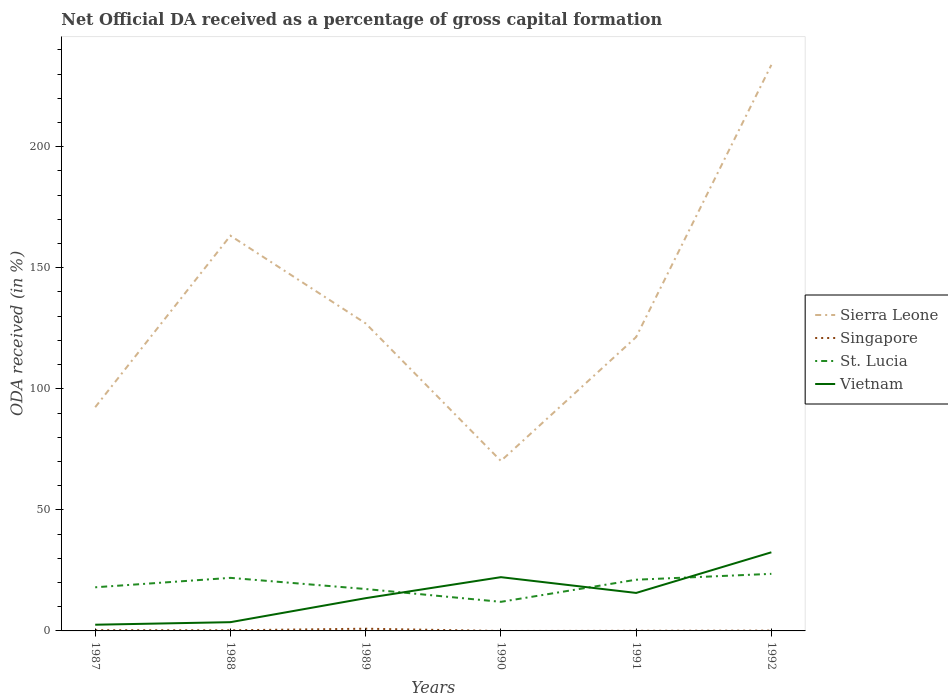Is the number of lines equal to the number of legend labels?
Your answer should be very brief. No. Across all years, what is the maximum net ODA received in Sierra Leone?
Provide a succinct answer. 70.21. What is the total net ODA received in Vietnam in the graph?
Your answer should be compact. -2.16. What is the difference between the highest and the second highest net ODA received in Sierra Leone?
Give a very brief answer. 163.58. How many years are there in the graph?
Offer a terse response. 6. Are the values on the major ticks of Y-axis written in scientific E-notation?
Give a very brief answer. No. Where does the legend appear in the graph?
Your answer should be compact. Center right. How are the legend labels stacked?
Provide a short and direct response. Vertical. What is the title of the graph?
Provide a short and direct response. Net Official DA received as a percentage of gross capital formation. Does "Faeroe Islands" appear as one of the legend labels in the graph?
Keep it short and to the point. No. What is the label or title of the Y-axis?
Provide a short and direct response. ODA received (in %). What is the ODA received (in %) of Sierra Leone in 1987?
Your answer should be very brief. 92.41. What is the ODA received (in %) in Singapore in 1987?
Offer a very short reply. 0.3. What is the ODA received (in %) of St. Lucia in 1987?
Provide a succinct answer. 18.02. What is the ODA received (in %) of Vietnam in 1987?
Make the answer very short. 2.56. What is the ODA received (in %) of Sierra Leone in 1988?
Your answer should be compact. 163.25. What is the ODA received (in %) in Singapore in 1988?
Provide a succinct answer. 0.26. What is the ODA received (in %) in St. Lucia in 1988?
Your response must be concise. 21.92. What is the ODA received (in %) of Vietnam in 1988?
Ensure brevity in your answer.  3.61. What is the ODA received (in %) in Sierra Leone in 1989?
Provide a succinct answer. 127.02. What is the ODA received (in %) in Singapore in 1989?
Make the answer very short. 0.91. What is the ODA received (in %) in St. Lucia in 1989?
Ensure brevity in your answer.  17.31. What is the ODA received (in %) in Vietnam in 1989?
Offer a terse response. 13.53. What is the ODA received (in %) of Sierra Leone in 1990?
Offer a terse response. 70.21. What is the ODA received (in %) in St. Lucia in 1990?
Your answer should be very brief. 12.02. What is the ODA received (in %) of Vietnam in 1990?
Offer a very short reply. 22.2. What is the ODA received (in %) in Sierra Leone in 1991?
Offer a very short reply. 121.37. What is the ODA received (in %) of Singapore in 1991?
Your answer should be very brief. 0.05. What is the ODA received (in %) of St. Lucia in 1991?
Make the answer very short. 21.15. What is the ODA received (in %) in Vietnam in 1991?
Your response must be concise. 15.69. What is the ODA received (in %) in Sierra Leone in 1992?
Your answer should be compact. 233.79. What is the ODA received (in %) of Singapore in 1992?
Give a very brief answer. 0.11. What is the ODA received (in %) of St. Lucia in 1992?
Ensure brevity in your answer.  23.58. What is the ODA received (in %) of Vietnam in 1992?
Make the answer very short. 32.47. Across all years, what is the maximum ODA received (in %) in Sierra Leone?
Your answer should be very brief. 233.79. Across all years, what is the maximum ODA received (in %) in Singapore?
Your answer should be very brief. 0.91. Across all years, what is the maximum ODA received (in %) in St. Lucia?
Provide a succinct answer. 23.58. Across all years, what is the maximum ODA received (in %) of Vietnam?
Your response must be concise. 32.47. Across all years, what is the minimum ODA received (in %) of Sierra Leone?
Give a very brief answer. 70.21. Across all years, what is the minimum ODA received (in %) of St. Lucia?
Your answer should be very brief. 12.02. Across all years, what is the minimum ODA received (in %) of Vietnam?
Keep it short and to the point. 2.56. What is the total ODA received (in %) in Sierra Leone in the graph?
Provide a succinct answer. 808.03. What is the total ODA received (in %) in Singapore in the graph?
Ensure brevity in your answer.  1.64. What is the total ODA received (in %) in St. Lucia in the graph?
Keep it short and to the point. 113.98. What is the total ODA received (in %) in Vietnam in the graph?
Keep it short and to the point. 90.06. What is the difference between the ODA received (in %) of Sierra Leone in 1987 and that in 1988?
Make the answer very short. -70.84. What is the difference between the ODA received (in %) of Singapore in 1987 and that in 1988?
Provide a succinct answer. 0.05. What is the difference between the ODA received (in %) in St. Lucia in 1987 and that in 1988?
Provide a short and direct response. -3.9. What is the difference between the ODA received (in %) of Vietnam in 1987 and that in 1988?
Your answer should be very brief. -1.06. What is the difference between the ODA received (in %) in Sierra Leone in 1987 and that in 1989?
Make the answer very short. -34.61. What is the difference between the ODA received (in %) in Singapore in 1987 and that in 1989?
Your answer should be very brief. -0.61. What is the difference between the ODA received (in %) in St. Lucia in 1987 and that in 1989?
Your answer should be compact. 0.71. What is the difference between the ODA received (in %) of Vietnam in 1987 and that in 1989?
Offer a very short reply. -10.97. What is the difference between the ODA received (in %) of Sierra Leone in 1987 and that in 1990?
Make the answer very short. 22.2. What is the difference between the ODA received (in %) of St. Lucia in 1987 and that in 1990?
Offer a terse response. 6. What is the difference between the ODA received (in %) of Vietnam in 1987 and that in 1990?
Ensure brevity in your answer.  -19.64. What is the difference between the ODA received (in %) of Sierra Leone in 1987 and that in 1991?
Ensure brevity in your answer.  -28.96. What is the difference between the ODA received (in %) in Singapore in 1987 and that in 1991?
Offer a very short reply. 0.25. What is the difference between the ODA received (in %) of St. Lucia in 1987 and that in 1991?
Provide a succinct answer. -3.13. What is the difference between the ODA received (in %) of Vietnam in 1987 and that in 1991?
Make the answer very short. -13.13. What is the difference between the ODA received (in %) in Sierra Leone in 1987 and that in 1992?
Your answer should be very brief. -141.38. What is the difference between the ODA received (in %) in Singapore in 1987 and that in 1992?
Offer a terse response. 0.2. What is the difference between the ODA received (in %) of St. Lucia in 1987 and that in 1992?
Give a very brief answer. -5.55. What is the difference between the ODA received (in %) in Vietnam in 1987 and that in 1992?
Make the answer very short. -29.91. What is the difference between the ODA received (in %) in Sierra Leone in 1988 and that in 1989?
Offer a terse response. 36.23. What is the difference between the ODA received (in %) in Singapore in 1988 and that in 1989?
Offer a very short reply. -0.66. What is the difference between the ODA received (in %) of St. Lucia in 1988 and that in 1989?
Keep it short and to the point. 4.61. What is the difference between the ODA received (in %) in Vietnam in 1988 and that in 1989?
Your answer should be very brief. -9.91. What is the difference between the ODA received (in %) in Sierra Leone in 1988 and that in 1990?
Keep it short and to the point. 93.04. What is the difference between the ODA received (in %) of St. Lucia in 1988 and that in 1990?
Your answer should be very brief. 9.9. What is the difference between the ODA received (in %) in Vietnam in 1988 and that in 1990?
Offer a terse response. -18.59. What is the difference between the ODA received (in %) in Sierra Leone in 1988 and that in 1991?
Your answer should be compact. 41.88. What is the difference between the ODA received (in %) in Singapore in 1988 and that in 1991?
Give a very brief answer. 0.21. What is the difference between the ODA received (in %) in St. Lucia in 1988 and that in 1991?
Make the answer very short. 0.77. What is the difference between the ODA received (in %) in Vietnam in 1988 and that in 1991?
Give a very brief answer. -12.07. What is the difference between the ODA received (in %) of Sierra Leone in 1988 and that in 1992?
Offer a very short reply. -70.54. What is the difference between the ODA received (in %) of Singapore in 1988 and that in 1992?
Your answer should be very brief. 0.15. What is the difference between the ODA received (in %) of St. Lucia in 1988 and that in 1992?
Offer a terse response. -1.66. What is the difference between the ODA received (in %) in Vietnam in 1988 and that in 1992?
Ensure brevity in your answer.  -28.86. What is the difference between the ODA received (in %) of Sierra Leone in 1989 and that in 1990?
Give a very brief answer. 56.81. What is the difference between the ODA received (in %) in St. Lucia in 1989 and that in 1990?
Provide a succinct answer. 5.29. What is the difference between the ODA received (in %) of Vietnam in 1989 and that in 1990?
Keep it short and to the point. -8.67. What is the difference between the ODA received (in %) of Sierra Leone in 1989 and that in 1991?
Offer a very short reply. 5.65. What is the difference between the ODA received (in %) in Singapore in 1989 and that in 1991?
Your answer should be very brief. 0.86. What is the difference between the ODA received (in %) in St. Lucia in 1989 and that in 1991?
Offer a very short reply. -3.84. What is the difference between the ODA received (in %) of Vietnam in 1989 and that in 1991?
Offer a very short reply. -2.16. What is the difference between the ODA received (in %) in Sierra Leone in 1989 and that in 1992?
Give a very brief answer. -106.77. What is the difference between the ODA received (in %) in Singapore in 1989 and that in 1992?
Your response must be concise. 0.81. What is the difference between the ODA received (in %) in St. Lucia in 1989 and that in 1992?
Provide a short and direct response. -6.27. What is the difference between the ODA received (in %) of Vietnam in 1989 and that in 1992?
Provide a short and direct response. -18.95. What is the difference between the ODA received (in %) of Sierra Leone in 1990 and that in 1991?
Offer a very short reply. -51.16. What is the difference between the ODA received (in %) in St. Lucia in 1990 and that in 1991?
Ensure brevity in your answer.  -9.13. What is the difference between the ODA received (in %) of Vietnam in 1990 and that in 1991?
Provide a succinct answer. 6.51. What is the difference between the ODA received (in %) of Sierra Leone in 1990 and that in 1992?
Provide a short and direct response. -163.58. What is the difference between the ODA received (in %) of St. Lucia in 1990 and that in 1992?
Give a very brief answer. -11.56. What is the difference between the ODA received (in %) of Vietnam in 1990 and that in 1992?
Offer a terse response. -10.27. What is the difference between the ODA received (in %) of Sierra Leone in 1991 and that in 1992?
Your response must be concise. -112.42. What is the difference between the ODA received (in %) of Singapore in 1991 and that in 1992?
Your answer should be very brief. -0.06. What is the difference between the ODA received (in %) in St. Lucia in 1991 and that in 1992?
Your answer should be compact. -2.43. What is the difference between the ODA received (in %) in Vietnam in 1991 and that in 1992?
Your answer should be very brief. -16.78. What is the difference between the ODA received (in %) of Sierra Leone in 1987 and the ODA received (in %) of Singapore in 1988?
Your answer should be very brief. 92.15. What is the difference between the ODA received (in %) of Sierra Leone in 1987 and the ODA received (in %) of St. Lucia in 1988?
Keep it short and to the point. 70.49. What is the difference between the ODA received (in %) in Sierra Leone in 1987 and the ODA received (in %) in Vietnam in 1988?
Keep it short and to the point. 88.79. What is the difference between the ODA received (in %) in Singapore in 1987 and the ODA received (in %) in St. Lucia in 1988?
Give a very brief answer. -21.61. What is the difference between the ODA received (in %) in Singapore in 1987 and the ODA received (in %) in Vietnam in 1988?
Offer a very short reply. -3.31. What is the difference between the ODA received (in %) of St. Lucia in 1987 and the ODA received (in %) of Vietnam in 1988?
Offer a terse response. 14.41. What is the difference between the ODA received (in %) of Sierra Leone in 1987 and the ODA received (in %) of Singapore in 1989?
Your answer should be compact. 91.49. What is the difference between the ODA received (in %) of Sierra Leone in 1987 and the ODA received (in %) of St. Lucia in 1989?
Keep it short and to the point. 75.1. What is the difference between the ODA received (in %) of Sierra Leone in 1987 and the ODA received (in %) of Vietnam in 1989?
Offer a very short reply. 78.88. What is the difference between the ODA received (in %) in Singapore in 1987 and the ODA received (in %) in St. Lucia in 1989?
Your answer should be compact. -17. What is the difference between the ODA received (in %) in Singapore in 1987 and the ODA received (in %) in Vietnam in 1989?
Offer a terse response. -13.22. What is the difference between the ODA received (in %) in St. Lucia in 1987 and the ODA received (in %) in Vietnam in 1989?
Provide a succinct answer. 4.49. What is the difference between the ODA received (in %) of Sierra Leone in 1987 and the ODA received (in %) of St. Lucia in 1990?
Ensure brevity in your answer.  80.39. What is the difference between the ODA received (in %) in Sierra Leone in 1987 and the ODA received (in %) in Vietnam in 1990?
Provide a succinct answer. 70.2. What is the difference between the ODA received (in %) of Singapore in 1987 and the ODA received (in %) of St. Lucia in 1990?
Ensure brevity in your answer.  -11.71. What is the difference between the ODA received (in %) of Singapore in 1987 and the ODA received (in %) of Vietnam in 1990?
Give a very brief answer. -21.9. What is the difference between the ODA received (in %) of St. Lucia in 1987 and the ODA received (in %) of Vietnam in 1990?
Offer a terse response. -4.18. What is the difference between the ODA received (in %) of Sierra Leone in 1987 and the ODA received (in %) of Singapore in 1991?
Your answer should be compact. 92.36. What is the difference between the ODA received (in %) of Sierra Leone in 1987 and the ODA received (in %) of St. Lucia in 1991?
Give a very brief answer. 71.26. What is the difference between the ODA received (in %) in Sierra Leone in 1987 and the ODA received (in %) in Vietnam in 1991?
Ensure brevity in your answer.  76.72. What is the difference between the ODA received (in %) of Singapore in 1987 and the ODA received (in %) of St. Lucia in 1991?
Make the answer very short. -20.84. What is the difference between the ODA received (in %) in Singapore in 1987 and the ODA received (in %) in Vietnam in 1991?
Give a very brief answer. -15.38. What is the difference between the ODA received (in %) in St. Lucia in 1987 and the ODA received (in %) in Vietnam in 1991?
Offer a very short reply. 2.33. What is the difference between the ODA received (in %) of Sierra Leone in 1987 and the ODA received (in %) of Singapore in 1992?
Make the answer very short. 92.3. What is the difference between the ODA received (in %) of Sierra Leone in 1987 and the ODA received (in %) of St. Lucia in 1992?
Your response must be concise. 68.83. What is the difference between the ODA received (in %) of Sierra Leone in 1987 and the ODA received (in %) of Vietnam in 1992?
Give a very brief answer. 59.93. What is the difference between the ODA received (in %) in Singapore in 1987 and the ODA received (in %) in St. Lucia in 1992?
Your answer should be very brief. -23.27. What is the difference between the ODA received (in %) in Singapore in 1987 and the ODA received (in %) in Vietnam in 1992?
Give a very brief answer. -32.17. What is the difference between the ODA received (in %) in St. Lucia in 1987 and the ODA received (in %) in Vietnam in 1992?
Your response must be concise. -14.45. What is the difference between the ODA received (in %) of Sierra Leone in 1988 and the ODA received (in %) of Singapore in 1989?
Your answer should be very brief. 162.33. What is the difference between the ODA received (in %) in Sierra Leone in 1988 and the ODA received (in %) in St. Lucia in 1989?
Give a very brief answer. 145.94. What is the difference between the ODA received (in %) in Sierra Leone in 1988 and the ODA received (in %) in Vietnam in 1989?
Make the answer very short. 149.72. What is the difference between the ODA received (in %) in Singapore in 1988 and the ODA received (in %) in St. Lucia in 1989?
Your answer should be compact. -17.05. What is the difference between the ODA received (in %) in Singapore in 1988 and the ODA received (in %) in Vietnam in 1989?
Give a very brief answer. -13.27. What is the difference between the ODA received (in %) in St. Lucia in 1988 and the ODA received (in %) in Vietnam in 1989?
Offer a very short reply. 8.39. What is the difference between the ODA received (in %) in Sierra Leone in 1988 and the ODA received (in %) in St. Lucia in 1990?
Your response must be concise. 151.23. What is the difference between the ODA received (in %) of Sierra Leone in 1988 and the ODA received (in %) of Vietnam in 1990?
Give a very brief answer. 141.04. What is the difference between the ODA received (in %) of Singapore in 1988 and the ODA received (in %) of St. Lucia in 1990?
Your answer should be very brief. -11.76. What is the difference between the ODA received (in %) of Singapore in 1988 and the ODA received (in %) of Vietnam in 1990?
Give a very brief answer. -21.94. What is the difference between the ODA received (in %) in St. Lucia in 1988 and the ODA received (in %) in Vietnam in 1990?
Give a very brief answer. -0.28. What is the difference between the ODA received (in %) in Sierra Leone in 1988 and the ODA received (in %) in Singapore in 1991?
Your answer should be very brief. 163.2. What is the difference between the ODA received (in %) of Sierra Leone in 1988 and the ODA received (in %) of St. Lucia in 1991?
Provide a short and direct response. 142.1. What is the difference between the ODA received (in %) of Sierra Leone in 1988 and the ODA received (in %) of Vietnam in 1991?
Provide a short and direct response. 147.56. What is the difference between the ODA received (in %) of Singapore in 1988 and the ODA received (in %) of St. Lucia in 1991?
Offer a terse response. -20.89. What is the difference between the ODA received (in %) of Singapore in 1988 and the ODA received (in %) of Vietnam in 1991?
Provide a short and direct response. -15.43. What is the difference between the ODA received (in %) of St. Lucia in 1988 and the ODA received (in %) of Vietnam in 1991?
Your answer should be compact. 6.23. What is the difference between the ODA received (in %) in Sierra Leone in 1988 and the ODA received (in %) in Singapore in 1992?
Offer a very short reply. 163.14. What is the difference between the ODA received (in %) of Sierra Leone in 1988 and the ODA received (in %) of St. Lucia in 1992?
Your answer should be compact. 139.67. What is the difference between the ODA received (in %) in Sierra Leone in 1988 and the ODA received (in %) in Vietnam in 1992?
Offer a terse response. 130.77. What is the difference between the ODA received (in %) in Singapore in 1988 and the ODA received (in %) in St. Lucia in 1992?
Your answer should be compact. -23.32. What is the difference between the ODA received (in %) of Singapore in 1988 and the ODA received (in %) of Vietnam in 1992?
Keep it short and to the point. -32.22. What is the difference between the ODA received (in %) in St. Lucia in 1988 and the ODA received (in %) in Vietnam in 1992?
Your response must be concise. -10.56. What is the difference between the ODA received (in %) in Sierra Leone in 1989 and the ODA received (in %) in St. Lucia in 1990?
Make the answer very short. 115. What is the difference between the ODA received (in %) in Sierra Leone in 1989 and the ODA received (in %) in Vietnam in 1990?
Your response must be concise. 104.81. What is the difference between the ODA received (in %) in Singapore in 1989 and the ODA received (in %) in St. Lucia in 1990?
Offer a very short reply. -11.1. What is the difference between the ODA received (in %) in Singapore in 1989 and the ODA received (in %) in Vietnam in 1990?
Give a very brief answer. -21.29. What is the difference between the ODA received (in %) of St. Lucia in 1989 and the ODA received (in %) of Vietnam in 1990?
Keep it short and to the point. -4.89. What is the difference between the ODA received (in %) in Sierra Leone in 1989 and the ODA received (in %) in Singapore in 1991?
Offer a terse response. 126.97. What is the difference between the ODA received (in %) in Sierra Leone in 1989 and the ODA received (in %) in St. Lucia in 1991?
Make the answer very short. 105.87. What is the difference between the ODA received (in %) in Sierra Leone in 1989 and the ODA received (in %) in Vietnam in 1991?
Provide a short and direct response. 111.33. What is the difference between the ODA received (in %) of Singapore in 1989 and the ODA received (in %) of St. Lucia in 1991?
Your answer should be compact. -20.24. What is the difference between the ODA received (in %) of Singapore in 1989 and the ODA received (in %) of Vietnam in 1991?
Offer a very short reply. -14.78. What is the difference between the ODA received (in %) in St. Lucia in 1989 and the ODA received (in %) in Vietnam in 1991?
Your answer should be very brief. 1.62. What is the difference between the ODA received (in %) in Sierra Leone in 1989 and the ODA received (in %) in Singapore in 1992?
Provide a short and direct response. 126.91. What is the difference between the ODA received (in %) of Sierra Leone in 1989 and the ODA received (in %) of St. Lucia in 1992?
Provide a succinct answer. 103.44. What is the difference between the ODA received (in %) in Sierra Leone in 1989 and the ODA received (in %) in Vietnam in 1992?
Make the answer very short. 94.54. What is the difference between the ODA received (in %) in Singapore in 1989 and the ODA received (in %) in St. Lucia in 1992?
Offer a very short reply. -22.66. What is the difference between the ODA received (in %) in Singapore in 1989 and the ODA received (in %) in Vietnam in 1992?
Keep it short and to the point. -31.56. What is the difference between the ODA received (in %) of St. Lucia in 1989 and the ODA received (in %) of Vietnam in 1992?
Your answer should be compact. -15.17. What is the difference between the ODA received (in %) of Sierra Leone in 1990 and the ODA received (in %) of Singapore in 1991?
Your answer should be very brief. 70.16. What is the difference between the ODA received (in %) in Sierra Leone in 1990 and the ODA received (in %) in St. Lucia in 1991?
Provide a short and direct response. 49.06. What is the difference between the ODA received (in %) in Sierra Leone in 1990 and the ODA received (in %) in Vietnam in 1991?
Offer a very short reply. 54.52. What is the difference between the ODA received (in %) in St. Lucia in 1990 and the ODA received (in %) in Vietnam in 1991?
Make the answer very short. -3.67. What is the difference between the ODA received (in %) of Sierra Leone in 1990 and the ODA received (in %) of Singapore in 1992?
Keep it short and to the point. 70.1. What is the difference between the ODA received (in %) of Sierra Leone in 1990 and the ODA received (in %) of St. Lucia in 1992?
Your answer should be very brief. 46.63. What is the difference between the ODA received (in %) in Sierra Leone in 1990 and the ODA received (in %) in Vietnam in 1992?
Provide a succinct answer. 37.73. What is the difference between the ODA received (in %) of St. Lucia in 1990 and the ODA received (in %) of Vietnam in 1992?
Offer a very short reply. -20.46. What is the difference between the ODA received (in %) in Sierra Leone in 1991 and the ODA received (in %) in Singapore in 1992?
Provide a succinct answer. 121.26. What is the difference between the ODA received (in %) of Sierra Leone in 1991 and the ODA received (in %) of St. Lucia in 1992?
Provide a succinct answer. 97.79. What is the difference between the ODA received (in %) of Sierra Leone in 1991 and the ODA received (in %) of Vietnam in 1992?
Your answer should be very brief. 88.9. What is the difference between the ODA received (in %) of Singapore in 1991 and the ODA received (in %) of St. Lucia in 1992?
Keep it short and to the point. -23.52. What is the difference between the ODA received (in %) in Singapore in 1991 and the ODA received (in %) in Vietnam in 1992?
Make the answer very short. -32.42. What is the difference between the ODA received (in %) of St. Lucia in 1991 and the ODA received (in %) of Vietnam in 1992?
Give a very brief answer. -11.32. What is the average ODA received (in %) in Sierra Leone per year?
Ensure brevity in your answer.  134.67. What is the average ODA received (in %) in Singapore per year?
Ensure brevity in your answer.  0.27. What is the average ODA received (in %) of St. Lucia per year?
Keep it short and to the point. 19. What is the average ODA received (in %) of Vietnam per year?
Provide a short and direct response. 15.01. In the year 1987, what is the difference between the ODA received (in %) of Sierra Leone and ODA received (in %) of Singapore?
Offer a terse response. 92.1. In the year 1987, what is the difference between the ODA received (in %) in Sierra Leone and ODA received (in %) in St. Lucia?
Keep it short and to the point. 74.39. In the year 1987, what is the difference between the ODA received (in %) in Sierra Leone and ODA received (in %) in Vietnam?
Provide a succinct answer. 89.85. In the year 1987, what is the difference between the ODA received (in %) in Singapore and ODA received (in %) in St. Lucia?
Make the answer very short. -17.72. In the year 1987, what is the difference between the ODA received (in %) of Singapore and ODA received (in %) of Vietnam?
Your answer should be very brief. -2.25. In the year 1987, what is the difference between the ODA received (in %) in St. Lucia and ODA received (in %) in Vietnam?
Provide a short and direct response. 15.46. In the year 1988, what is the difference between the ODA received (in %) of Sierra Leone and ODA received (in %) of Singapore?
Provide a succinct answer. 162.99. In the year 1988, what is the difference between the ODA received (in %) in Sierra Leone and ODA received (in %) in St. Lucia?
Your answer should be very brief. 141.33. In the year 1988, what is the difference between the ODA received (in %) of Sierra Leone and ODA received (in %) of Vietnam?
Give a very brief answer. 159.63. In the year 1988, what is the difference between the ODA received (in %) of Singapore and ODA received (in %) of St. Lucia?
Ensure brevity in your answer.  -21.66. In the year 1988, what is the difference between the ODA received (in %) of Singapore and ODA received (in %) of Vietnam?
Give a very brief answer. -3.36. In the year 1988, what is the difference between the ODA received (in %) in St. Lucia and ODA received (in %) in Vietnam?
Offer a very short reply. 18.3. In the year 1989, what is the difference between the ODA received (in %) of Sierra Leone and ODA received (in %) of Singapore?
Provide a succinct answer. 126.1. In the year 1989, what is the difference between the ODA received (in %) in Sierra Leone and ODA received (in %) in St. Lucia?
Make the answer very short. 109.71. In the year 1989, what is the difference between the ODA received (in %) of Sierra Leone and ODA received (in %) of Vietnam?
Give a very brief answer. 113.49. In the year 1989, what is the difference between the ODA received (in %) in Singapore and ODA received (in %) in St. Lucia?
Make the answer very short. -16.39. In the year 1989, what is the difference between the ODA received (in %) in Singapore and ODA received (in %) in Vietnam?
Your response must be concise. -12.61. In the year 1989, what is the difference between the ODA received (in %) of St. Lucia and ODA received (in %) of Vietnam?
Your answer should be very brief. 3.78. In the year 1990, what is the difference between the ODA received (in %) of Sierra Leone and ODA received (in %) of St. Lucia?
Provide a succinct answer. 58.19. In the year 1990, what is the difference between the ODA received (in %) in Sierra Leone and ODA received (in %) in Vietnam?
Offer a terse response. 48.01. In the year 1990, what is the difference between the ODA received (in %) of St. Lucia and ODA received (in %) of Vietnam?
Give a very brief answer. -10.18. In the year 1991, what is the difference between the ODA received (in %) of Sierra Leone and ODA received (in %) of Singapore?
Keep it short and to the point. 121.32. In the year 1991, what is the difference between the ODA received (in %) of Sierra Leone and ODA received (in %) of St. Lucia?
Ensure brevity in your answer.  100.22. In the year 1991, what is the difference between the ODA received (in %) of Sierra Leone and ODA received (in %) of Vietnam?
Make the answer very short. 105.68. In the year 1991, what is the difference between the ODA received (in %) in Singapore and ODA received (in %) in St. Lucia?
Make the answer very short. -21.1. In the year 1991, what is the difference between the ODA received (in %) in Singapore and ODA received (in %) in Vietnam?
Provide a short and direct response. -15.64. In the year 1991, what is the difference between the ODA received (in %) in St. Lucia and ODA received (in %) in Vietnam?
Make the answer very short. 5.46. In the year 1992, what is the difference between the ODA received (in %) in Sierra Leone and ODA received (in %) in Singapore?
Your answer should be compact. 233.68. In the year 1992, what is the difference between the ODA received (in %) of Sierra Leone and ODA received (in %) of St. Lucia?
Give a very brief answer. 210.22. In the year 1992, what is the difference between the ODA received (in %) of Sierra Leone and ODA received (in %) of Vietnam?
Your answer should be very brief. 201.32. In the year 1992, what is the difference between the ODA received (in %) of Singapore and ODA received (in %) of St. Lucia?
Keep it short and to the point. -23.47. In the year 1992, what is the difference between the ODA received (in %) in Singapore and ODA received (in %) in Vietnam?
Keep it short and to the point. -32.37. In the year 1992, what is the difference between the ODA received (in %) in St. Lucia and ODA received (in %) in Vietnam?
Your answer should be compact. -8.9. What is the ratio of the ODA received (in %) in Sierra Leone in 1987 to that in 1988?
Keep it short and to the point. 0.57. What is the ratio of the ODA received (in %) of Singapore in 1987 to that in 1988?
Your answer should be compact. 1.18. What is the ratio of the ODA received (in %) of St. Lucia in 1987 to that in 1988?
Give a very brief answer. 0.82. What is the ratio of the ODA received (in %) of Vietnam in 1987 to that in 1988?
Keep it short and to the point. 0.71. What is the ratio of the ODA received (in %) in Sierra Leone in 1987 to that in 1989?
Your response must be concise. 0.73. What is the ratio of the ODA received (in %) of St. Lucia in 1987 to that in 1989?
Offer a very short reply. 1.04. What is the ratio of the ODA received (in %) of Vietnam in 1987 to that in 1989?
Provide a short and direct response. 0.19. What is the ratio of the ODA received (in %) in Sierra Leone in 1987 to that in 1990?
Offer a terse response. 1.32. What is the ratio of the ODA received (in %) of St. Lucia in 1987 to that in 1990?
Your response must be concise. 1.5. What is the ratio of the ODA received (in %) in Vietnam in 1987 to that in 1990?
Provide a short and direct response. 0.12. What is the ratio of the ODA received (in %) in Sierra Leone in 1987 to that in 1991?
Your answer should be very brief. 0.76. What is the ratio of the ODA received (in %) of Singapore in 1987 to that in 1991?
Your answer should be very brief. 6.06. What is the ratio of the ODA received (in %) in St. Lucia in 1987 to that in 1991?
Give a very brief answer. 0.85. What is the ratio of the ODA received (in %) in Vietnam in 1987 to that in 1991?
Your answer should be compact. 0.16. What is the ratio of the ODA received (in %) in Sierra Leone in 1987 to that in 1992?
Make the answer very short. 0.4. What is the ratio of the ODA received (in %) of Singapore in 1987 to that in 1992?
Your answer should be compact. 2.83. What is the ratio of the ODA received (in %) in St. Lucia in 1987 to that in 1992?
Keep it short and to the point. 0.76. What is the ratio of the ODA received (in %) of Vietnam in 1987 to that in 1992?
Ensure brevity in your answer.  0.08. What is the ratio of the ODA received (in %) of Sierra Leone in 1988 to that in 1989?
Make the answer very short. 1.29. What is the ratio of the ODA received (in %) in Singapore in 1988 to that in 1989?
Provide a succinct answer. 0.28. What is the ratio of the ODA received (in %) in St. Lucia in 1988 to that in 1989?
Make the answer very short. 1.27. What is the ratio of the ODA received (in %) of Vietnam in 1988 to that in 1989?
Keep it short and to the point. 0.27. What is the ratio of the ODA received (in %) of Sierra Leone in 1988 to that in 1990?
Ensure brevity in your answer.  2.33. What is the ratio of the ODA received (in %) of St. Lucia in 1988 to that in 1990?
Make the answer very short. 1.82. What is the ratio of the ODA received (in %) of Vietnam in 1988 to that in 1990?
Make the answer very short. 0.16. What is the ratio of the ODA received (in %) in Sierra Leone in 1988 to that in 1991?
Ensure brevity in your answer.  1.34. What is the ratio of the ODA received (in %) of Singapore in 1988 to that in 1991?
Your answer should be compact. 5.14. What is the ratio of the ODA received (in %) in St. Lucia in 1988 to that in 1991?
Keep it short and to the point. 1.04. What is the ratio of the ODA received (in %) in Vietnam in 1988 to that in 1991?
Provide a succinct answer. 0.23. What is the ratio of the ODA received (in %) of Sierra Leone in 1988 to that in 1992?
Make the answer very short. 0.7. What is the ratio of the ODA received (in %) of Singapore in 1988 to that in 1992?
Your answer should be very brief. 2.4. What is the ratio of the ODA received (in %) of St. Lucia in 1988 to that in 1992?
Your response must be concise. 0.93. What is the ratio of the ODA received (in %) of Vietnam in 1988 to that in 1992?
Keep it short and to the point. 0.11. What is the ratio of the ODA received (in %) in Sierra Leone in 1989 to that in 1990?
Give a very brief answer. 1.81. What is the ratio of the ODA received (in %) of St. Lucia in 1989 to that in 1990?
Keep it short and to the point. 1.44. What is the ratio of the ODA received (in %) in Vietnam in 1989 to that in 1990?
Keep it short and to the point. 0.61. What is the ratio of the ODA received (in %) in Sierra Leone in 1989 to that in 1991?
Offer a very short reply. 1.05. What is the ratio of the ODA received (in %) of Singapore in 1989 to that in 1991?
Provide a succinct answer. 18.17. What is the ratio of the ODA received (in %) of St. Lucia in 1989 to that in 1991?
Give a very brief answer. 0.82. What is the ratio of the ODA received (in %) of Vietnam in 1989 to that in 1991?
Keep it short and to the point. 0.86. What is the ratio of the ODA received (in %) of Sierra Leone in 1989 to that in 1992?
Provide a succinct answer. 0.54. What is the ratio of the ODA received (in %) of Singapore in 1989 to that in 1992?
Offer a very short reply. 8.49. What is the ratio of the ODA received (in %) of St. Lucia in 1989 to that in 1992?
Your answer should be compact. 0.73. What is the ratio of the ODA received (in %) in Vietnam in 1989 to that in 1992?
Your response must be concise. 0.42. What is the ratio of the ODA received (in %) in Sierra Leone in 1990 to that in 1991?
Make the answer very short. 0.58. What is the ratio of the ODA received (in %) of St. Lucia in 1990 to that in 1991?
Ensure brevity in your answer.  0.57. What is the ratio of the ODA received (in %) in Vietnam in 1990 to that in 1991?
Ensure brevity in your answer.  1.42. What is the ratio of the ODA received (in %) of Sierra Leone in 1990 to that in 1992?
Provide a short and direct response. 0.3. What is the ratio of the ODA received (in %) in St. Lucia in 1990 to that in 1992?
Ensure brevity in your answer.  0.51. What is the ratio of the ODA received (in %) of Vietnam in 1990 to that in 1992?
Provide a succinct answer. 0.68. What is the ratio of the ODA received (in %) in Sierra Leone in 1991 to that in 1992?
Your answer should be very brief. 0.52. What is the ratio of the ODA received (in %) of Singapore in 1991 to that in 1992?
Keep it short and to the point. 0.47. What is the ratio of the ODA received (in %) of St. Lucia in 1991 to that in 1992?
Offer a terse response. 0.9. What is the ratio of the ODA received (in %) of Vietnam in 1991 to that in 1992?
Keep it short and to the point. 0.48. What is the difference between the highest and the second highest ODA received (in %) in Sierra Leone?
Ensure brevity in your answer.  70.54. What is the difference between the highest and the second highest ODA received (in %) in Singapore?
Your answer should be compact. 0.61. What is the difference between the highest and the second highest ODA received (in %) in St. Lucia?
Give a very brief answer. 1.66. What is the difference between the highest and the second highest ODA received (in %) of Vietnam?
Give a very brief answer. 10.27. What is the difference between the highest and the lowest ODA received (in %) of Sierra Leone?
Offer a very short reply. 163.58. What is the difference between the highest and the lowest ODA received (in %) of Singapore?
Offer a very short reply. 0.91. What is the difference between the highest and the lowest ODA received (in %) of St. Lucia?
Provide a short and direct response. 11.56. What is the difference between the highest and the lowest ODA received (in %) in Vietnam?
Give a very brief answer. 29.91. 